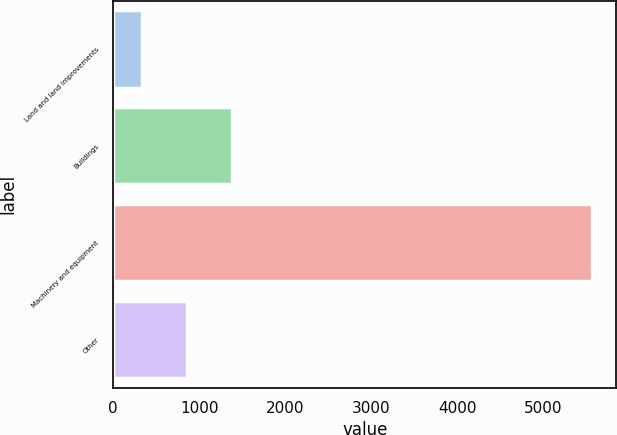Convert chart to OTSL. <chart><loc_0><loc_0><loc_500><loc_500><bar_chart><fcel>Land and land improvements<fcel>Buildings<fcel>Machinery and equipment<fcel>Other<nl><fcel>332<fcel>1380<fcel>5572<fcel>856<nl></chart> 